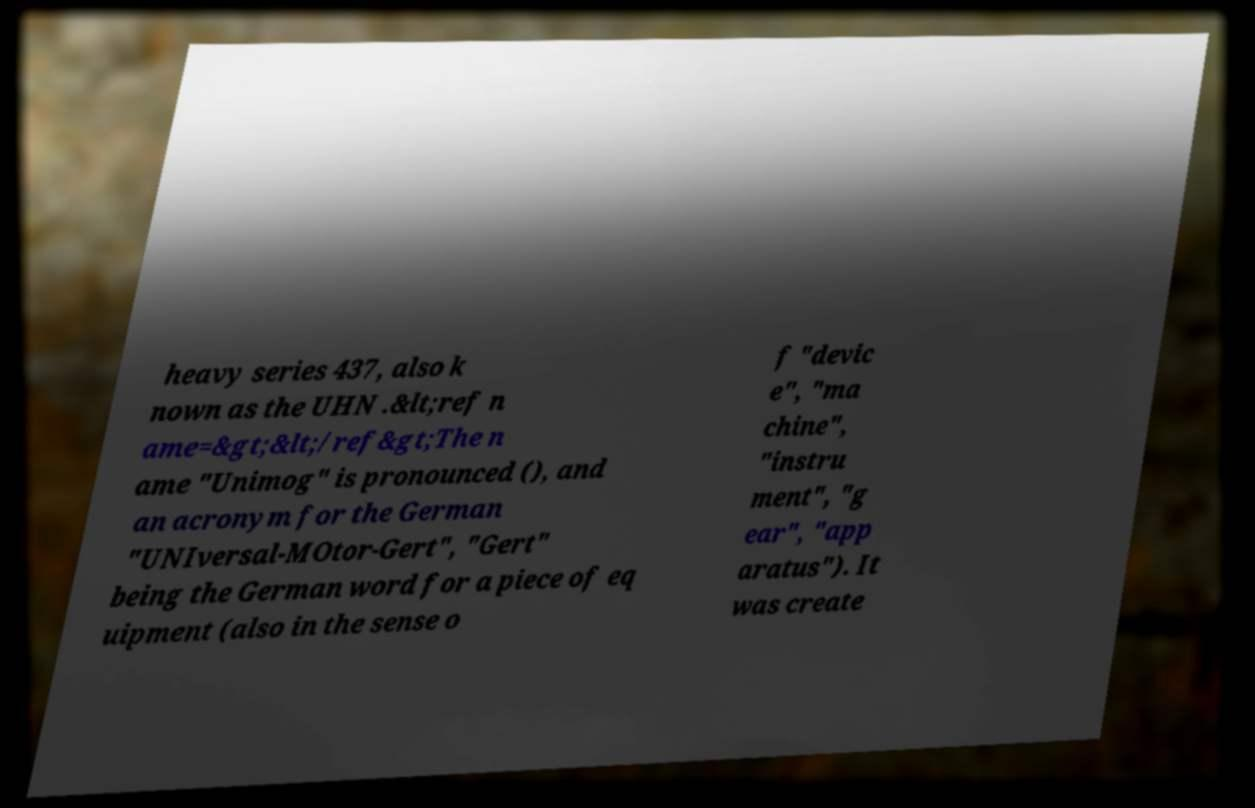Can you accurately transcribe the text from the provided image for me? heavy series 437, also k nown as the UHN .&lt;ref n ame=&gt;&lt;/ref&gt;The n ame "Unimog" is pronounced (), and an acronym for the German "UNIversal-MOtor-Gert", "Gert" being the German word for a piece of eq uipment (also in the sense o f "devic e", "ma chine", "instru ment", "g ear", "app aratus"). It was create 